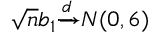<formula> <loc_0><loc_0><loc_500><loc_500>{ \sqrt { n } } b _ { 1 } { \xrightarrow { d } } N ( 0 , 6 )</formula> 